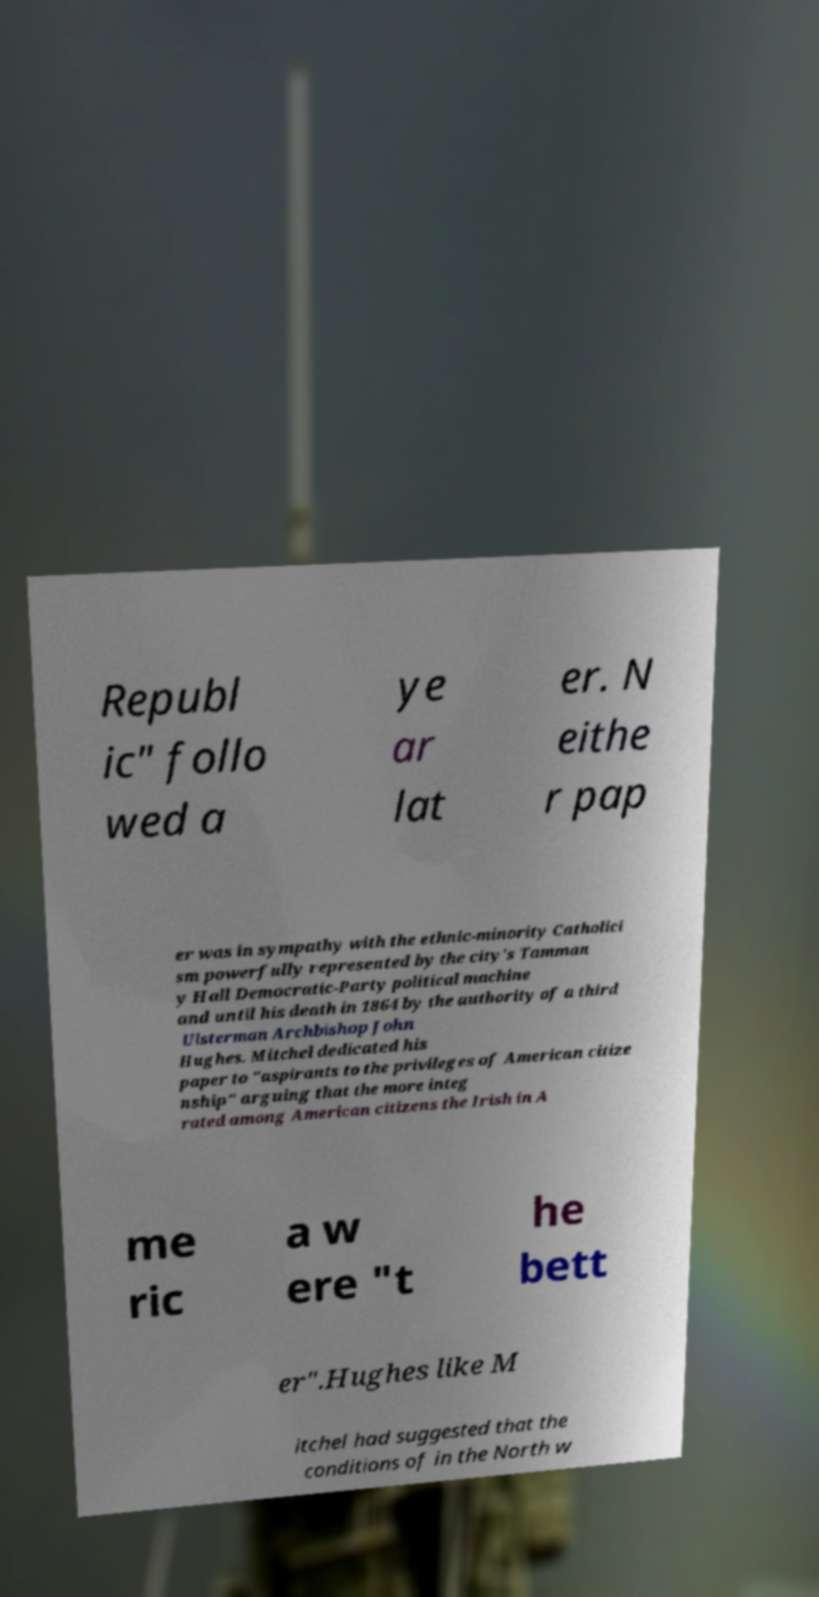Please read and relay the text visible in this image. What does it say? Republ ic" follo wed a ye ar lat er. N eithe r pap er was in sympathy with the ethnic-minority Catholici sm powerfully represented by the city's Tamman y Hall Democratic-Party political machine and until his death in 1864 by the authority of a third Ulsterman Archbishop John Hughes. Mitchel dedicated his paper to "aspirants to the privileges of American citize nship" arguing that the more integ rated among American citizens the Irish in A me ric a w ere "t he bett er".Hughes like M itchel had suggested that the conditions of in the North w 